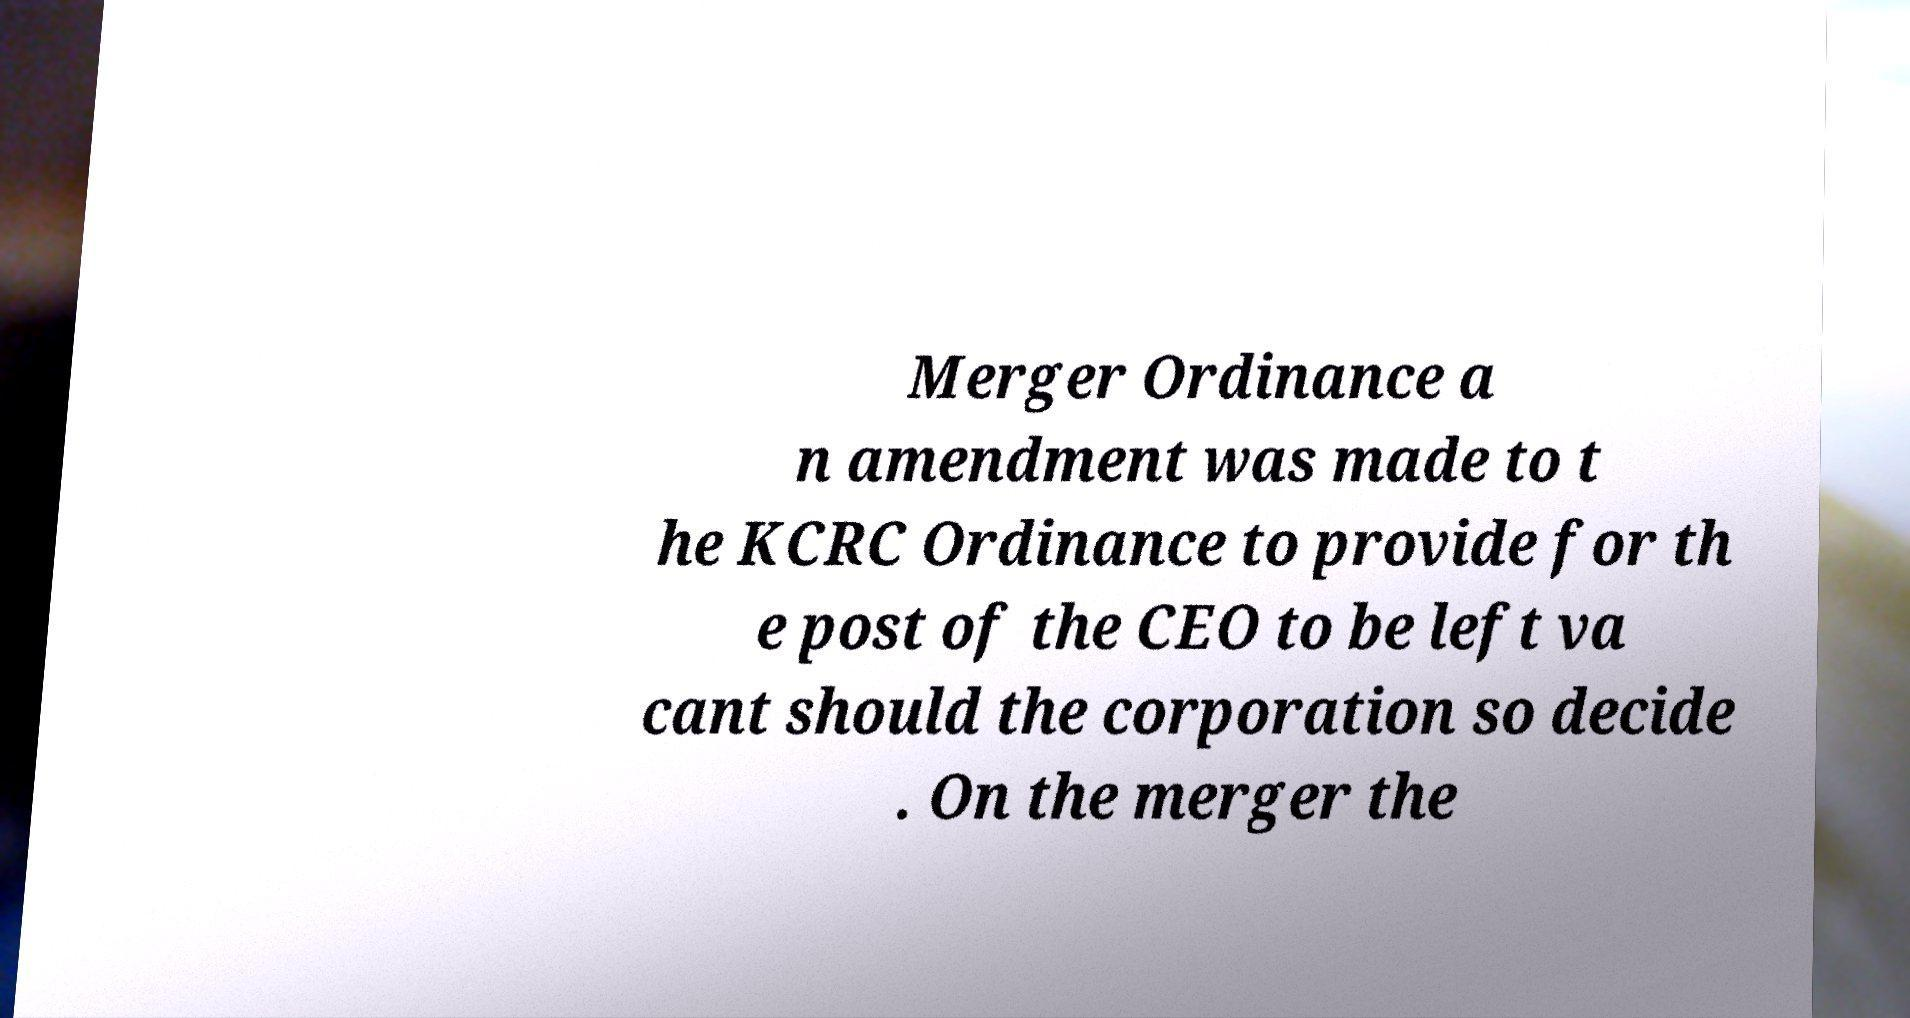I need the written content from this picture converted into text. Can you do that? Merger Ordinance a n amendment was made to t he KCRC Ordinance to provide for th e post of the CEO to be left va cant should the corporation so decide . On the merger the 